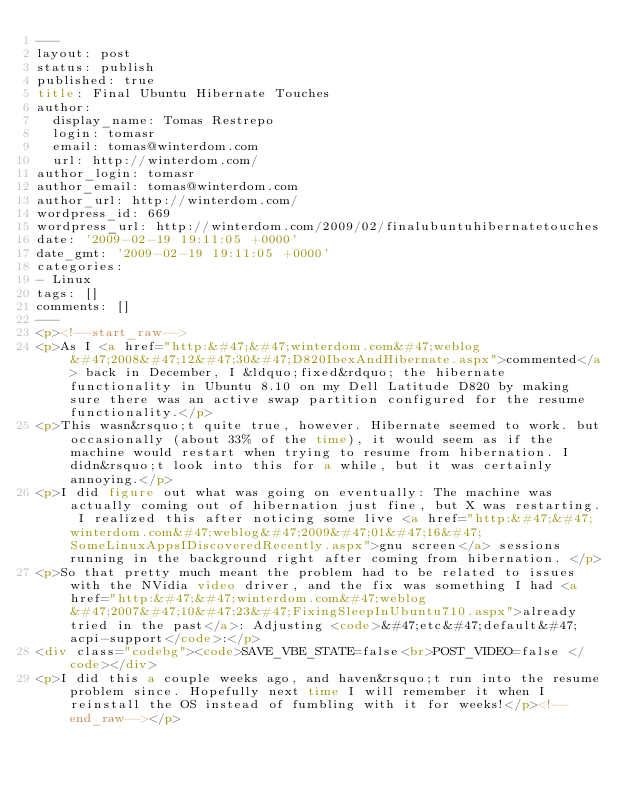Convert code to text. <code><loc_0><loc_0><loc_500><loc_500><_HTML_>---
layout: post
status: publish
published: true
title: Final Ubuntu Hibernate Touches
author:
  display_name: Tomas Restrepo
  login: tomasr
  email: tomas@winterdom.com
  url: http://winterdom.com/
author_login: tomasr
author_email: tomas@winterdom.com
author_url: http://winterdom.com/
wordpress_id: 669
wordpress_url: http://winterdom.com/2009/02/finalubuntuhibernatetouches
date: '2009-02-19 19:11:05 +0000'
date_gmt: '2009-02-19 19:11:05 +0000'
categories:
- Linux
tags: []
comments: []
---
<p><!--start_raw-->
<p>As I <a href="http:&#47;&#47;winterdom.com&#47;weblog&#47;2008&#47;12&#47;30&#47;D820IbexAndHibernate.aspx">commented</a> back in December, I &ldquo;fixed&rdquo; the hibernate functionality in Ubuntu 8.10 on my Dell Latitude D820 by making sure there was an active swap partition configured for the resume functionality.</p>
<p>This wasn&rsquo;t quite true, however. Hibernate seemed to work. but occasionally (about 33% of the time), it would seem as if the machine would restart when trying to resume from hibernation. I didn&rsquo;t look into this for a while, but it was certainly annoying.</p>
<p>I did figure out what was going on eventually: The machine was actually coming out of hibernation just fine, but X was restarting. I realized this after noticing some live <a href="http:&#47;&#47;winterdom.com&#47;weblog&#47;2009&#47;01&#47;16&#47;SomeLinuxAppsIDiscoveredRecently.aspx">gnu screen</a> sessions running in the background right after coming from hibernation. </p>
<p>So that pretty much meant the problem had to be related to issues with the NVidia video driver, and the fix was something I had <a href="http:&#47;&#47;winterdom.com&#47;weblog&#47;2007&#47;10&#47;23&#47;FixingSleepInUbuntu710.aspx">already tried in the past</a>: Adjusting <code>&#47;etc&#47;default&#47;acpi-support</code>:</p>
<div class="codebg"><code>SAVE_VBE_STATE=false<br>POST_VIDEO=false </code></div>
<p>I did this a couple weeks ago, and haven&rsquo;t run into the resume problem since. Hopefully next time I will remember it when I reinstall the OS instead of fumbling with it for weeks!</p><!--end_raw--></p>
</code> 